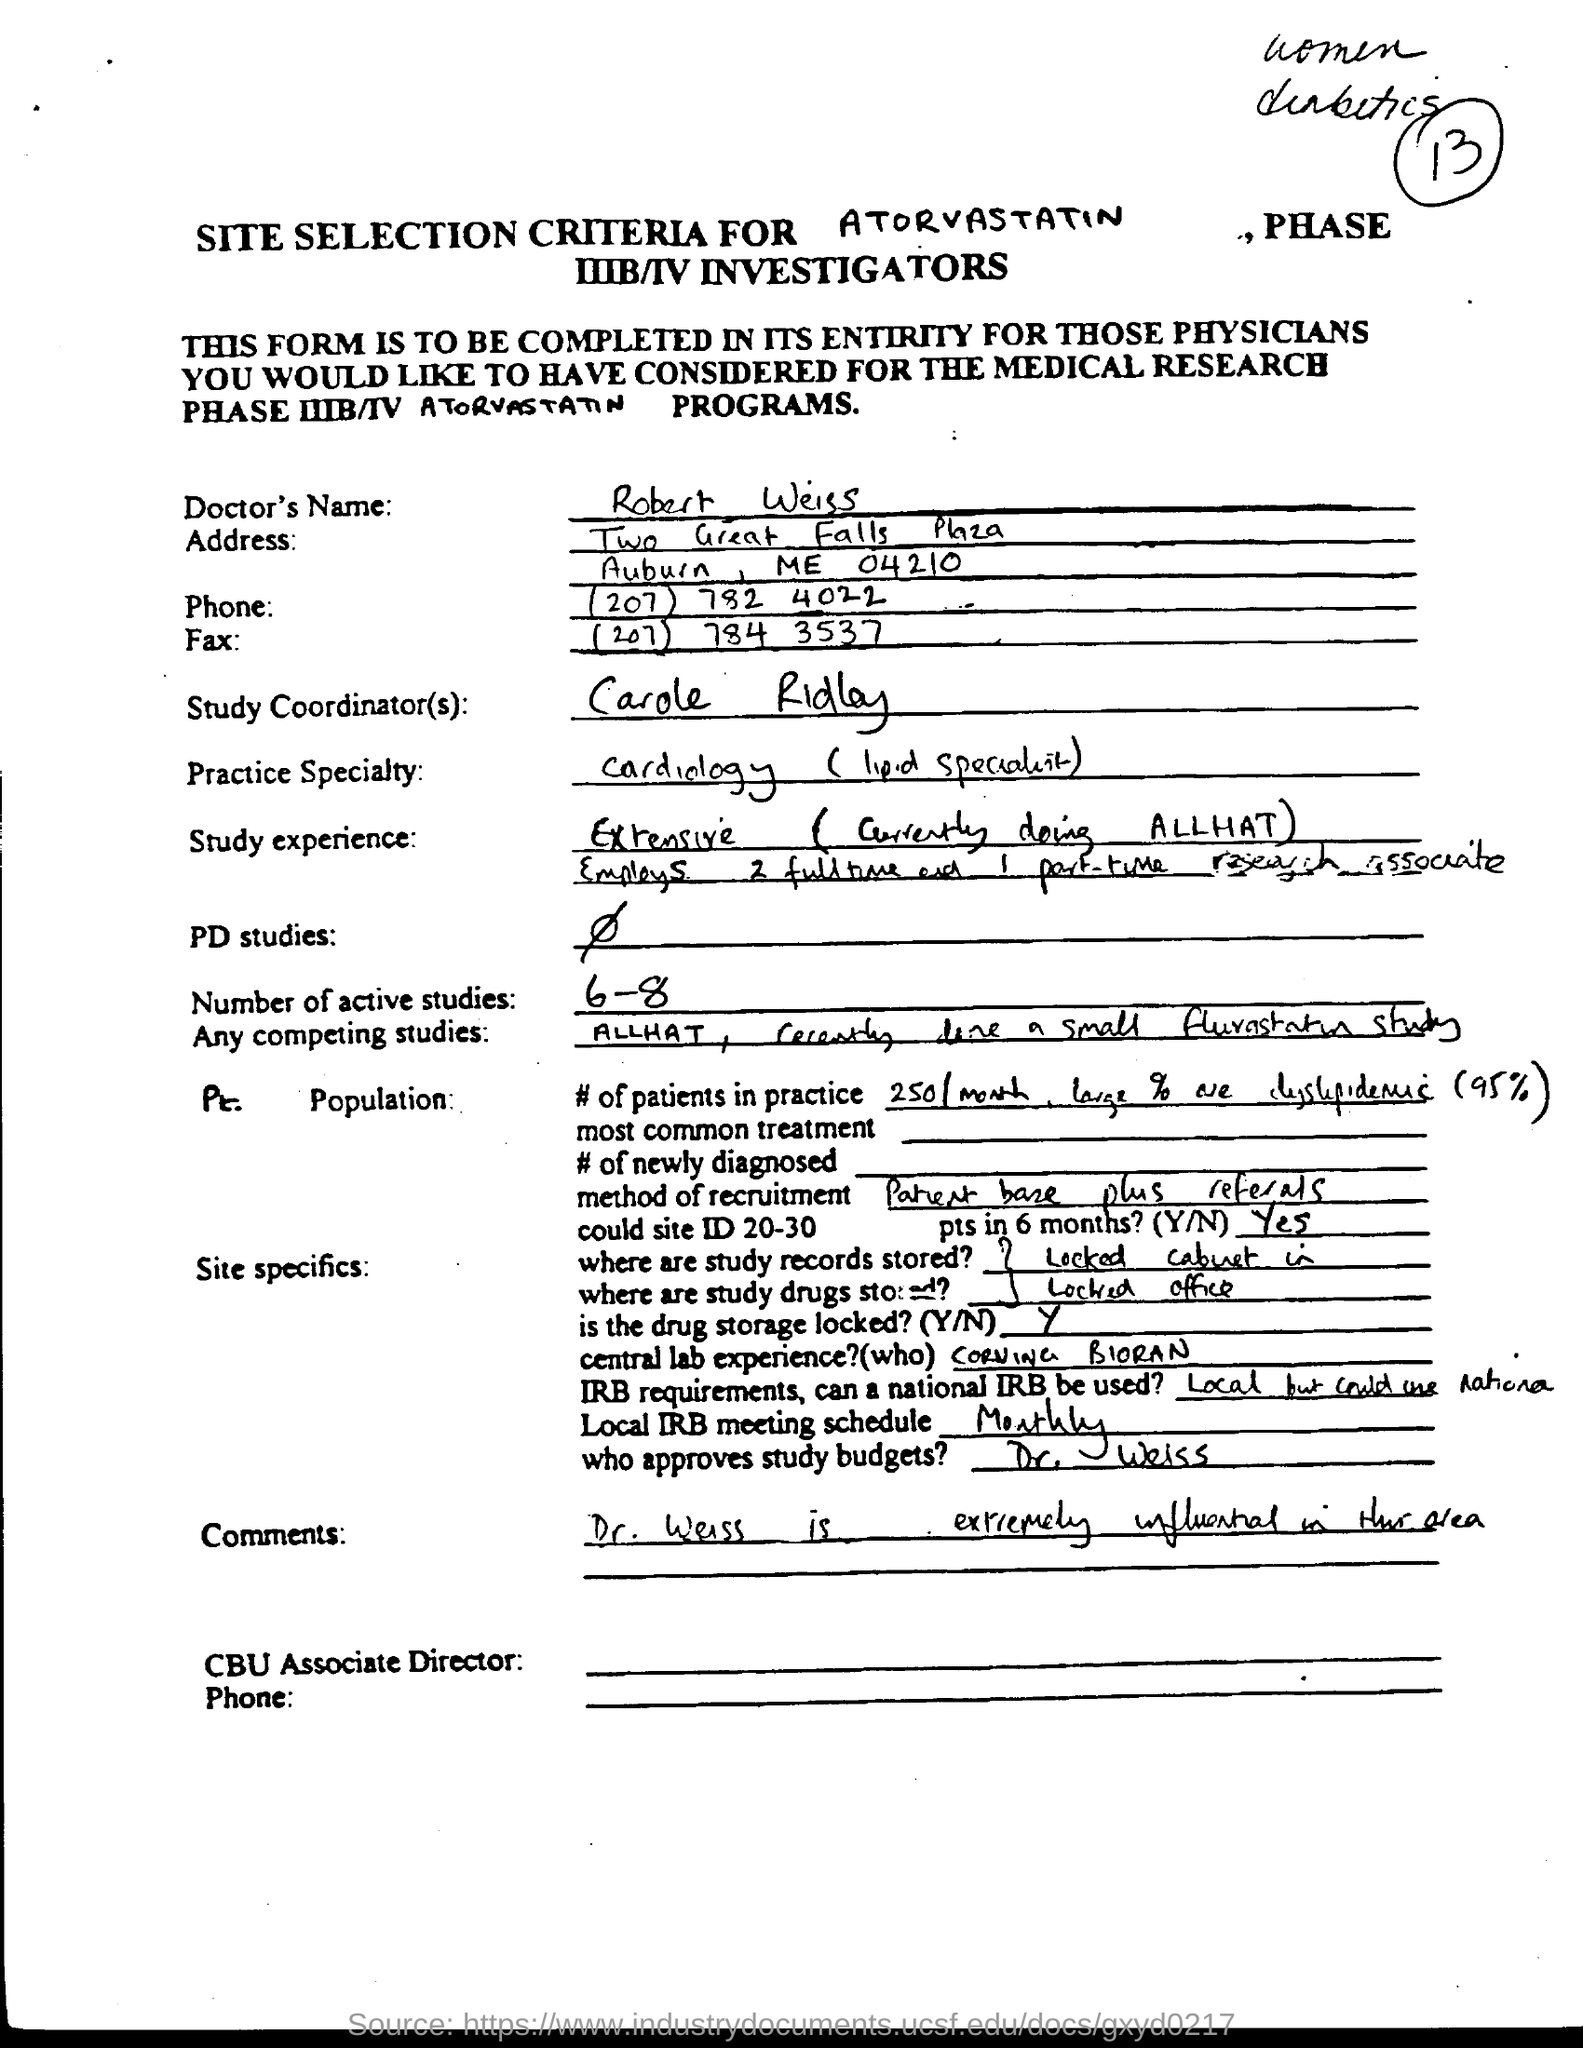What is doctor's name ?
Provide a short and direct response. Robert Weiss. What is the phone no.?
Your response must be concise. (207) 782 4022. What is the fax no.?
Ensure brevity in your answer.  (207) 784 3537. 